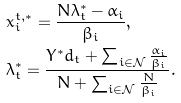Convert formula to latex. <formula><loc_0><loc_0><loc_500><loc_500>& x _ { i } ^ { t , * } = \frac { N \lambda _ { t } ^ { * } - \alpha _ { i } } { \beta _ { i } } , \\ & \lambda _ { t } ^ { * } = \frac { Y ^ { * } d _ { t } + \sum _ { i \in \mathcal { N } } \frac { \alpha _ { i } } { \beta _ { i } } } { N + \sum _ { i \in \mathcal { N } } \frac { N } { \beta _ { i } } } .</formula> 